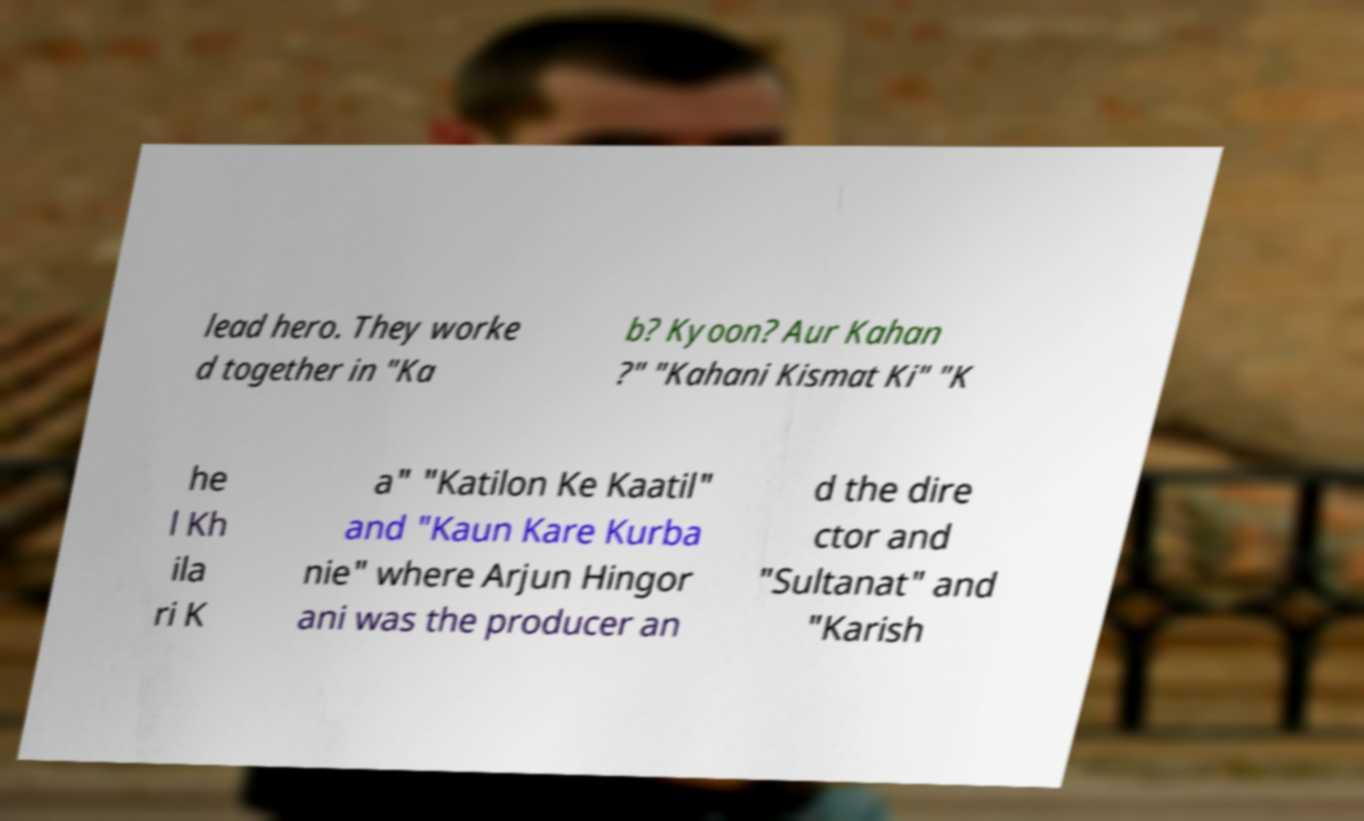There's text embedded in this image that I need extracted. Can you transcribe it verbatim? lead hero. They worke d together in "Ka b? Kyoon? Aur Kahan ?" "Kahani Kismat Ki" "K he l Kh ila ri K a" "Katilon Ke Kaatil" and "Kaun Kare Kurba nie" where Arjun Hingor ani was the producer an d the dire ctor and "Sultanat" and "Karish 